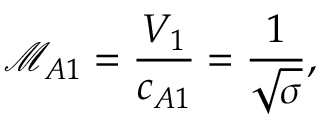<formula> <loc_0><loc_0><loc_500><loc_500>\mathcal { M } _ { A 1 } = \frac { V _ { 1 } } { c _ { A 1 } } = \frac { 1 } { \sqrt { \sigma } } ,</formula> 